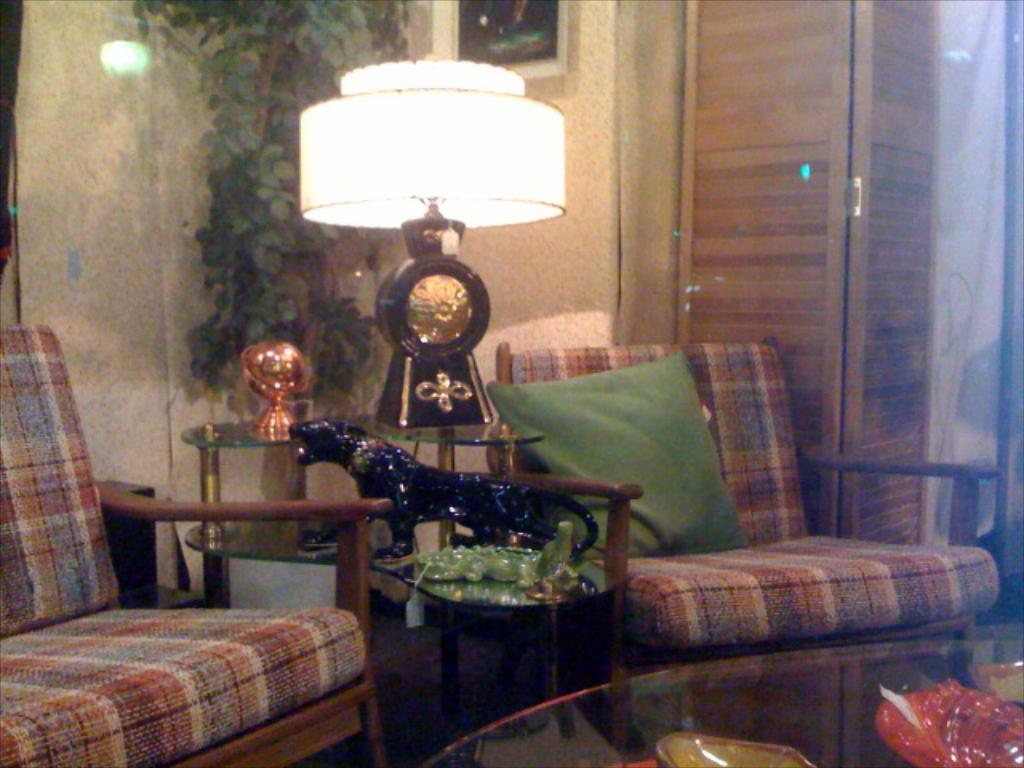Please provide a concise description of this image. These are the couches. I can see a table with toys, a lamp and few other things on it. This looks like a cushion. I think this is a houseplant. I can see a photo frame, which is attached to the wall. This looks like a wooden door. I think this is a glass table with few objects on it. 